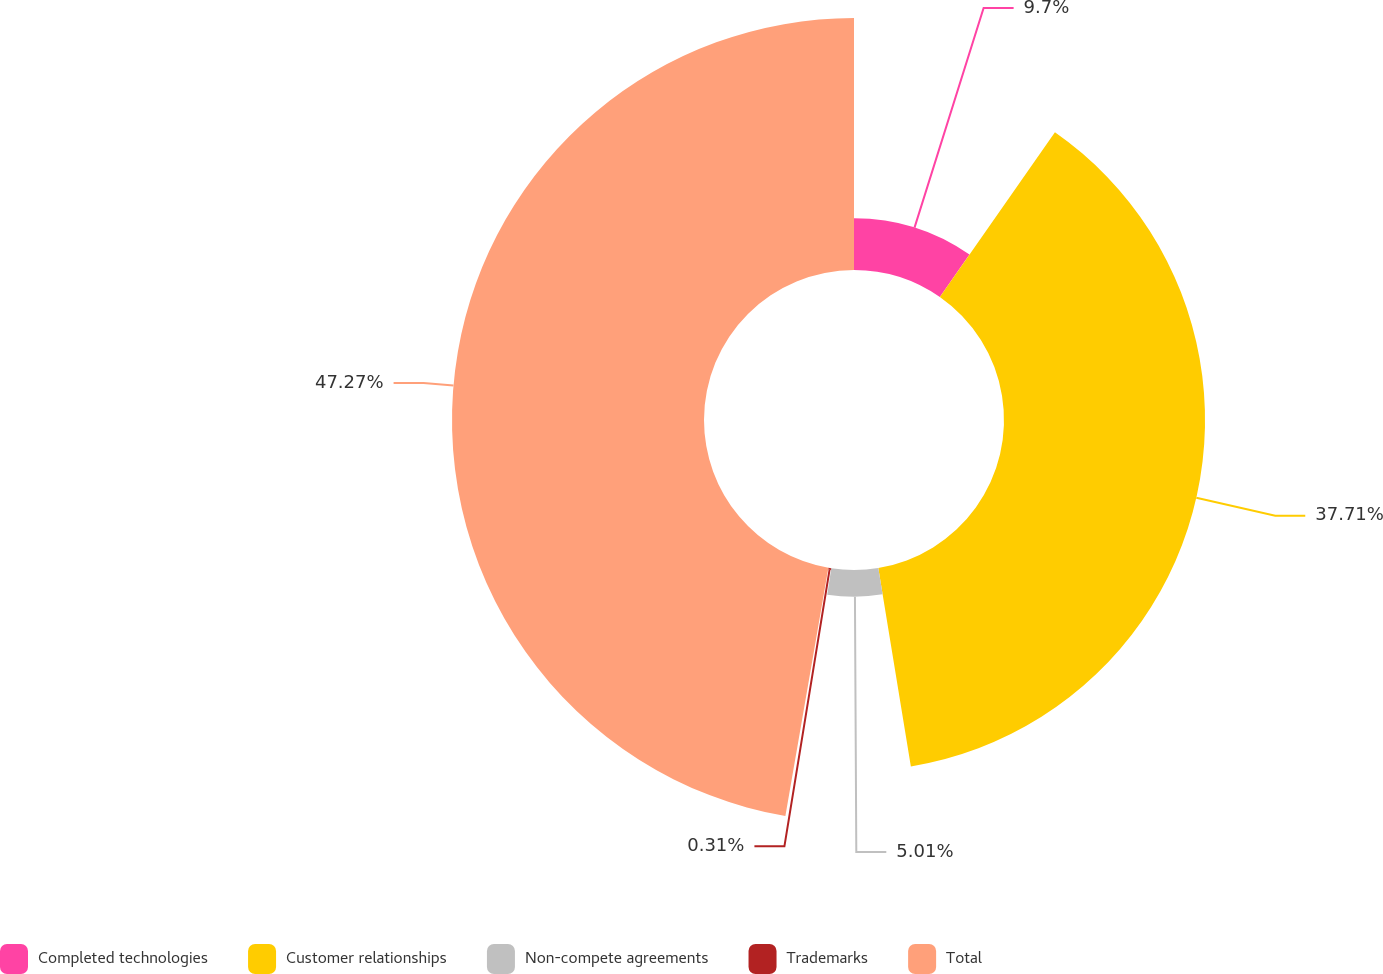<chart> <loc_0><loc_0><loc_500><loc_500><pie_chart><fcel>Completed technologies<fcel>Customer relationships<fcel>Non-compete agreements<fcel>Trademarks<fcel>Total<nl><fcel>9.7%<fcel>37.71%<fcel>5.01%<fcel>0.31%<fcel>47.27%<nl></chart> 